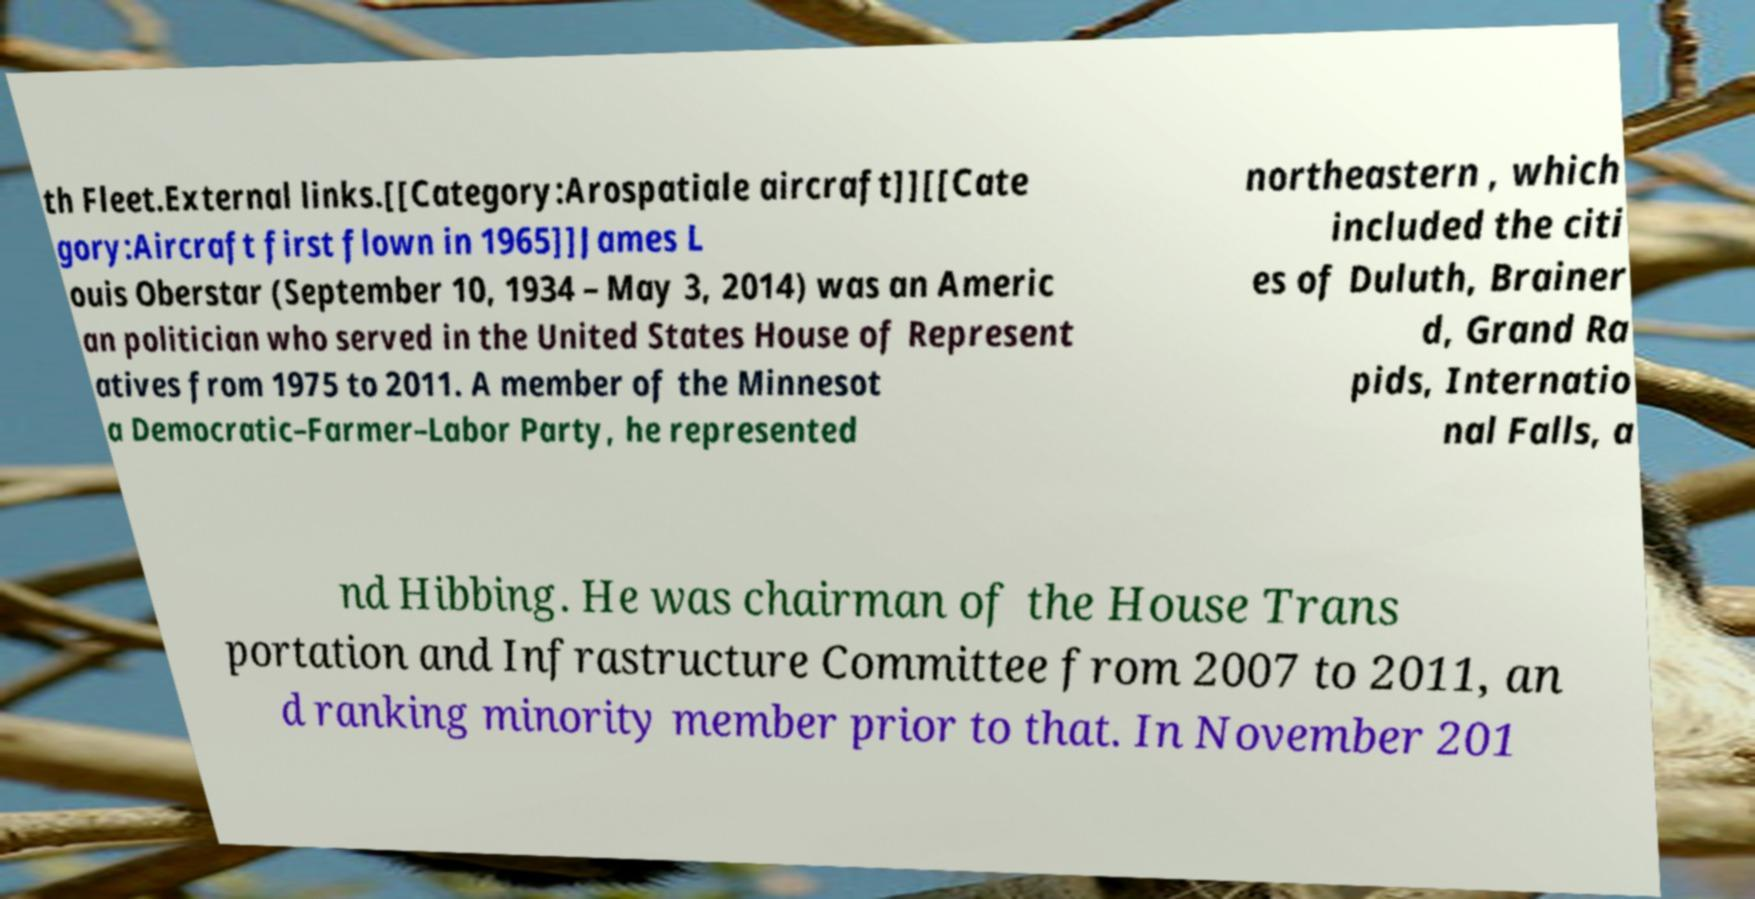Can you accurately transcribe the text from the provided image for me? th Fleet.External links.[[Category:Arospatiale aircraft]][[Cate gory:Aircraft first flown in 1965]]James L ouis Oberstar (September 10, 1934 – May 3, 2014) was an Americ an politician who served in the United States House of Represent atives from 1975 to 2011. A member of the Minnesot a Democratic–Farmer–Labor Party, he represented northeastern , which included the citi es of Duluth, Brainer d, Grand Ra pids, Internatio nal Falls, a nd Hibbing. He was chairman of the House Trans portation and Infrastructure Committee from 2007 to 2011, an d ranking minority member prior to that. In November 201 